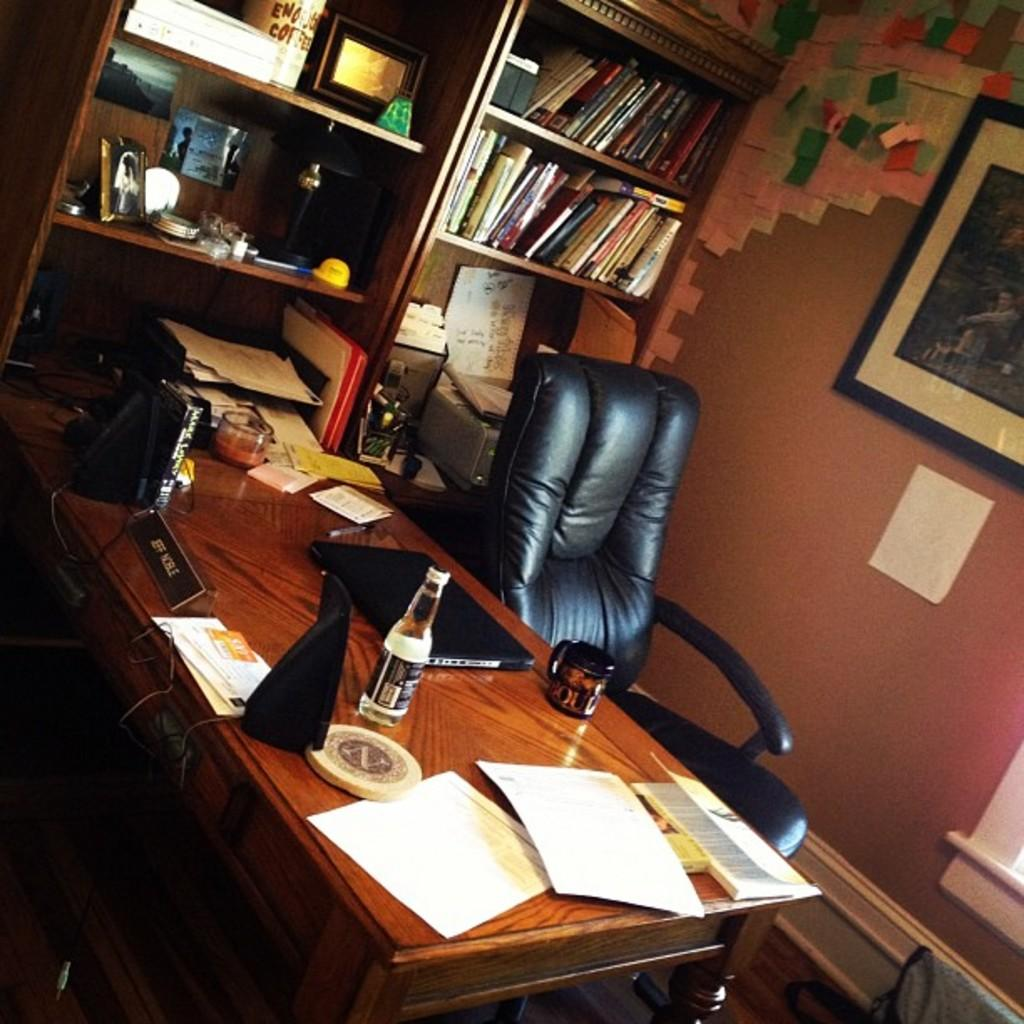What type of furniture is present in the image? There is a table and a chair in the image. What items can be seen on the table? There is a bottle, a laptop, paper, and a board on the table. What can be found in the background of the image? There are wallpapers, a frame, a cupboard, and books in the background. What type of cloth is draped over the sun in the image? There is no cloth or sun present in the image. What is the limit of the laptop's battery life in the image? The image does not provide information about the laptop's battery life, so it cannot be determined. 